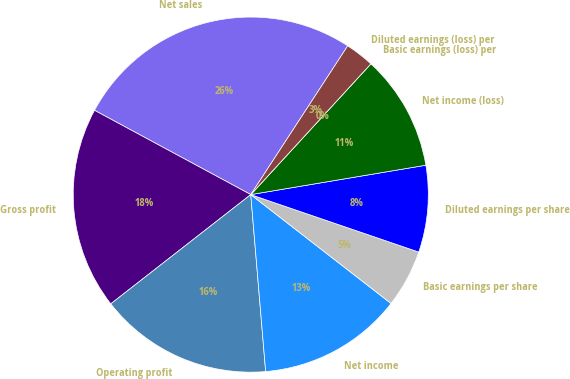<chart> <loc_0><loc_0><loc_500><loc_500><pie_chart><fcel>Net sales<fcel>Gross profit<fcel>Operating profit<fcel>Net income<fcel>Basic earnings per share<fcel>Diluted earnings per share<fcel>Net income (loss)<fcel>Basic earnings (loss) per<fcel>Diluted earnings (loss) per<nl><fcel>26.32%<fcel>18.42%<fcel>15.79%<fcel>13.16%<fcel>5.26%<fcel>7.89%<fcel>10.53%<fcel>0.0%<fcel>2.63%<nl></chart> 